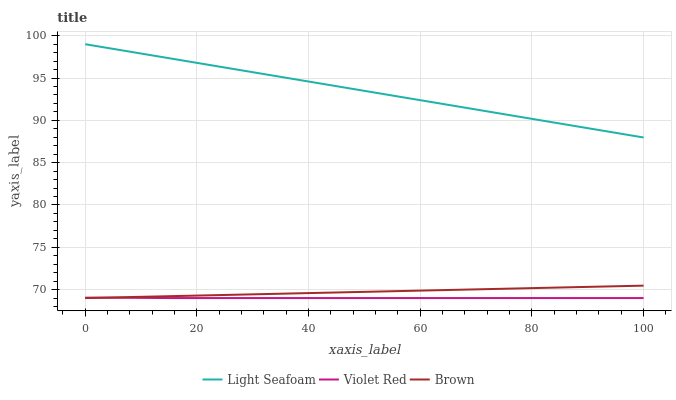Does Violet Red have the minimum area under the curve?
Answer yes or no. Yes. Does Light Seafoam have the maximum area under the curve?
Answer yes or no. Yes. Does Light Seafoam have the minimum area under the curve?
Answer yes or no. No. Does Violet Red have the maximum area under the curve?
Answer yes or no. No. Is Light Seafoam the smoothest?
Answer yes or no. Yes. Is Violet Red the roughest?
Answer yes or no. Yes. Is Violet Red the smoothest?
Answer yes or no. No. Is Light Seafoam the roughest?
Answer yes or no. No. Does Light Seafoam have the lowest value?
Answer yes or no. No. Does Violet Red have the highest value?
Answer yes or no. No. Is Violet Red less than Light Seafoam?
Answer yes or no. Yes. Is Light Seafoam greater than Violet Red?
Answer yes or no. Yes. Does Violet Red intersect Light Seafoam?
Answer yes or no. No. 